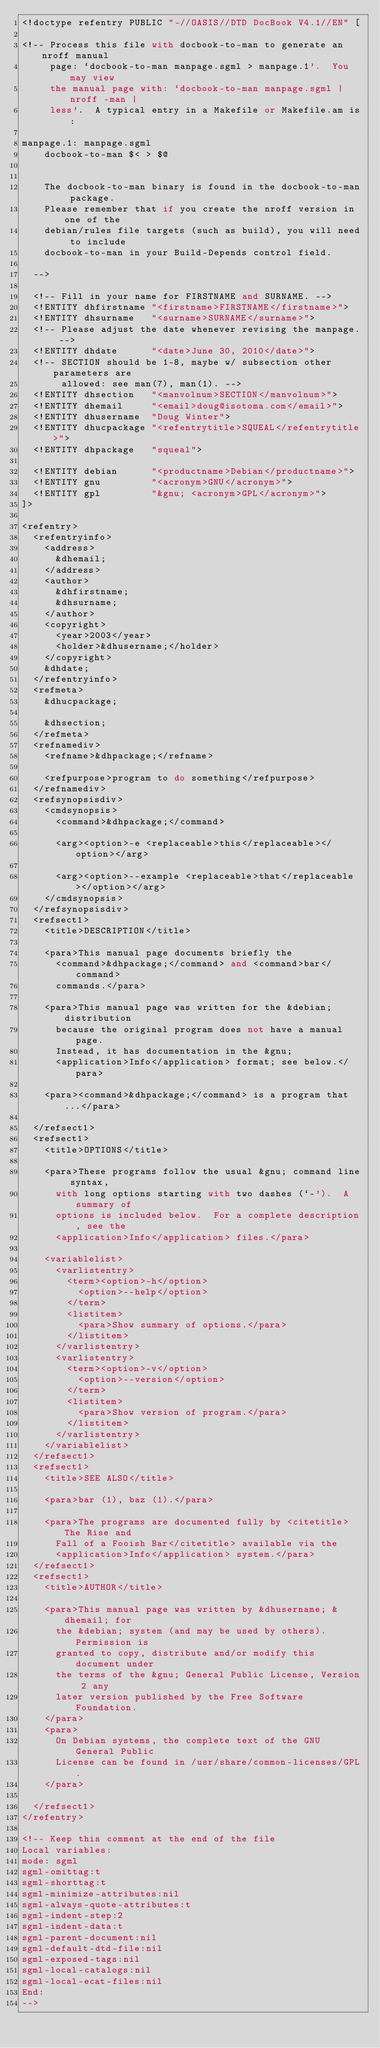Convert code to text. <code><loc_0><loc_0><loc_500><loc_500><_Elixir_><!doctype refentry PUBLIC "-//OASIS//DTD DocBook V4.1//EN" [

<!-- Process this file with docbook-to-man to generate an nroff manual
     page: `docbook-to-man manpage.sgml > manpage.1'.  You may view
     the manual page with: `docbook-to-man manpage.sgml | nroff -man |
     less'.  A typical entry in a Makefile or Makefile.am is:

manpage.1: manpage.sgml
	docbook-to-man $< > $@


	The docbook-to-man binary is found in the docbook-to-man package.
	Please remember that if you create the nroff version in one of the
	debian/rules file targets (such as build), you will need to include
	docbook-to-man in your Build-Depends control field.

  -->

  <!-- Fill in your name for FIRSTNAME and SURNAME. -->
  <!ENTITY dhfirstname "<firstname>FIRSTNAME</firstname>">
  <!ENTITY dhsurname   "<surname>SURNAME</surname>">
  <!-- Please adjust the date whenever revising the manpage. -->
  <!ENTITY dhdate      "<date>June 30, 2010</date>">
  <!-- SECTION should be 1-8, maybe w/ subsection other parameters are
       allowed: see man(7), man(1). -->
  <!ENTITY dhsection   "<manvolnum>SECTION</manvolnum>">
  <!ENTITY dhemail     "<email>doug@isotoma.com</email>">
  <!ENTITY dhusername  "Doug Winter">
  <!ENTITY dhucpackage "<refentrytitle>SQUEAL</refentrytitle>">
  <!ENTITY dhpackage   "squeal">

  <!ENTITY debian      "<productname>Debian</productname>">
  <!ENTITY gnu         "<acronym>GNU</acronym>">
  <!ENTITY gpl         "&gnu; <acronym>GPL</acronym>">
]>

<refentry>
  <refentryinfo>
    <address>
      &dhemail;
    </address>
    <author>
      &dhfirstname;
      &dhsurname;
    </author>
    <copyright>
      <year>2003</year>
      <holder>&dhusername;</holder>
    </copyright>
    &dhdate;
  </refentryinfo>
  <refmeta>
    &dhucpackage;

    &dhsection;
  </refmeta>
  <refnamediv>
    <refname>&dhpackage;</refname>

    <refpurpose>program to do something</refpurpose>
  </refnamediv>
  <refsynopsisdiv>
    <cmdsynopsis>
      <command>&dhpackage;</command>

      <arg><option>-e <replaceable>this</replaceable></option></arg>

      <arg><option>--example <replaceable>that</replaceable></option></arg>
    </cmdsynopsis>
  </refsynopsisdiv>
  <refsect1>
    <title>DESCRIPTION</title>

    <para>This manual page documents briefly the
      <command>&dhpackage;</command> and <command>bar</command>
      commands.</para>

    <para>This manual page was written for the &debian; distribution
      because the original program does not have a manual page.
      Instead, it has documentation in the &gnu;
      <application>Info</application> format; see below.</para>

    <para><command>&dhpackage;</command> is a program that...</para>

  </refsect1>
  <refsect1>
    <title>OPTIONS</title>

    <para>These programs follow the usual &gnu; command line syntax,
      with long options starting with two dashes (`-').  A summary of
      options is included below.  For a complete description, see the
      <application>Info</application> files.</para>

    <variablelist>
      <varlistentry>
        <term><option>-h</option>
          <option>--help</option>
        </term>
        <listitem>
          <para>Show summary of options.</para>
        </listitem>
      </varlistentry>
      <varlistentry>
        <term><option>-v</option>
          <option>--version</option>
        </term>
        <listitem>
          <para>Show version of program.</para>
        </listitem>
      </varlistentry>
    </variablelist>
  </refsect1>
  <refsect1>
    <title>SEE ALSO</title>

    <para>bar (1), baz (1).</para>

    <para>The programs are documented fully by <citetitle>The Rise and
      Fall of a Fooish Bar</citetitle> available via the
      <application>Info</application> system.</para>
  </refsect1>
  <refsect1>
    <title>AUTHOR</title>

    <para>This manual page was written by &dhusername; &dhemail; for
      the &debian; system (and may be used by others).  Permission is
      granted to copy, distribute and/or modify this document under
      the terms of the &gnu; General Public License, Version 2 any
      later version published by the Free Software Foundation.
    </para>
    <para>
      On Debian systems, the complete text of the GNU General Public
      License can be found in /usr/share/common-licenses/GPL.
    </para>

  </refsect1>
</refentry>

<!-- Keep this comment at the end of the file
Local variables:
mode: sgml
sgml-omittag:t
sgml-shorttag:t
sgml-minimize-attributes:nil
sgml-always-quote-attributes:t
sgml-indent-step:2
sgml-indent-data:t
sgml-parent-document:nil
sgml-default-dtd-file:nil
sgml-exposed-tags:nil
sgml-local-catalogs:nil
sgml-local-ecat-files:nil
End:
-->
</code> 